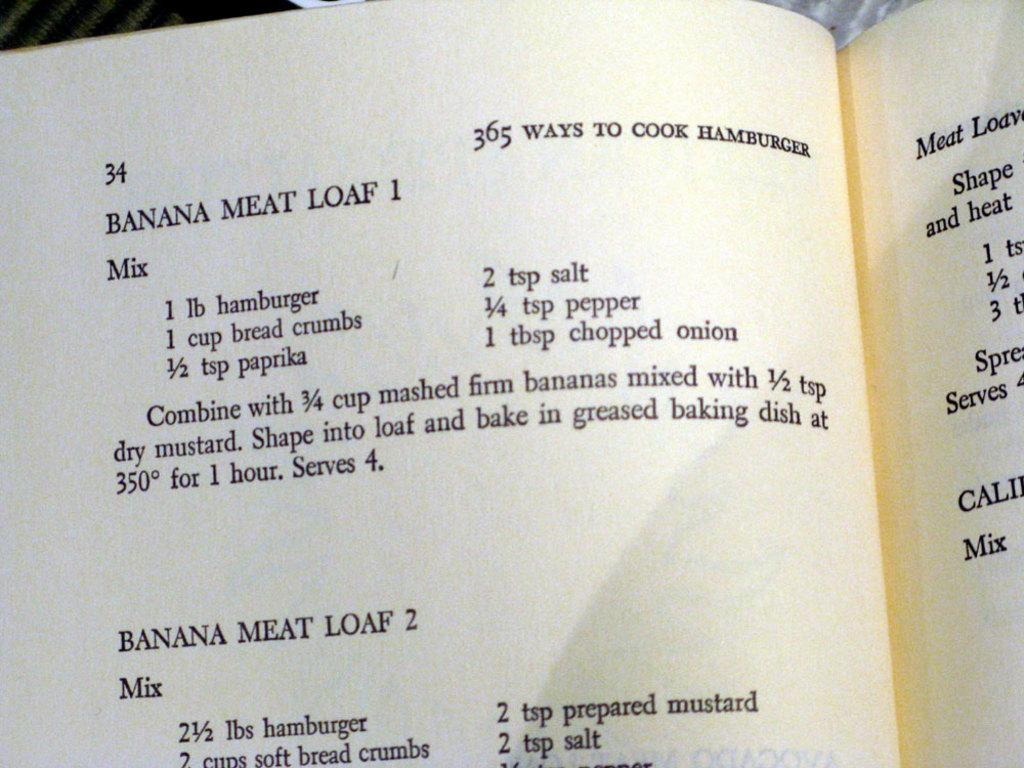<image>
Present a compact description of the photo's key features. Book open to a recipe for banana meat loaf 